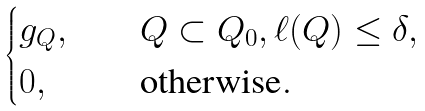<formula> <loc_0><loc_0><loc_500><loc_500>\begin{cases} g _ { Q } , & \quad Q \subset Q _ { 0 } , \ell ( Q ) \leq \delta , \\ 0 , & \quad \text {otherwise} . \end{cases}</formula> 